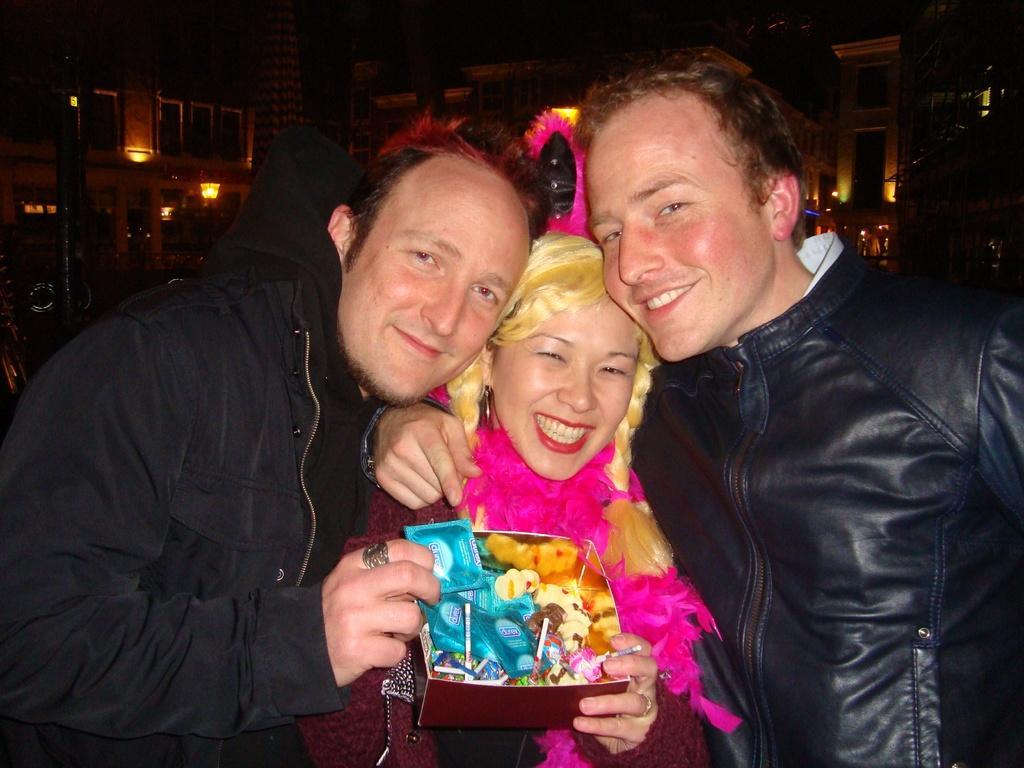In one or two sentences, can you explain what this image depicts? In front of the picture, we see two men and the women are standing. The girl is holding a box like. Behind them, we see buildings and street lights. This picture is clicked in the dark. 